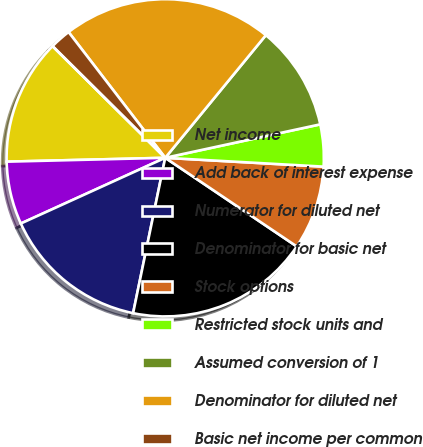<chart> <loc_0><loc_0><loc_500><loc_500><pie_chart><fcel>Net income<fcel>Add back of interest expense<fcel>Numerator for diluted net<fcel>Denominator for basic net<fcel>Stock options<fcel>Restricted stock units and<fcel>Assumed conversion of 1<fcel>Denominator for diluted net<fcel>Basic net income per common<fcel>Diluted net income per common<nl><fcel>12.82%<fcel>6.41%<fcel>14.96%<fcel>18.81%<fcel>8.55%<fcel>4.27%<fcel>10.68%<fcel>21.37%<fcel>2.14%<fcel>0.0%<nl></chart> 